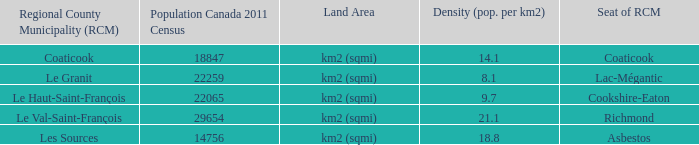7? Le Haut-Saint-François. 